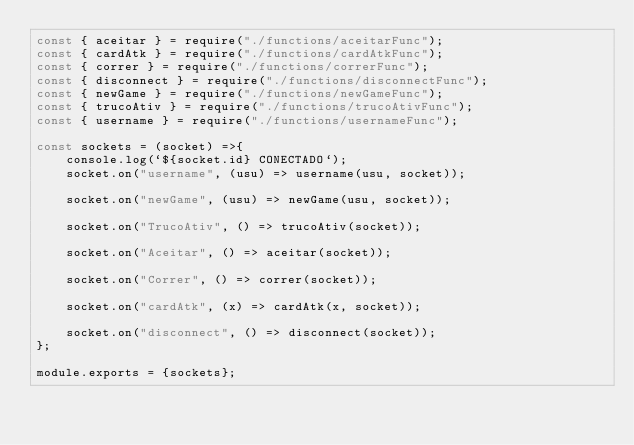Convert code to text. <code><loc_0><loc_0><loc_500><loc_500><_JavaScript_>const { aceitar } = require("./functions/aceitarFunc");
const { cardAtk } = require("./functions/cardAtkFunc");
const { correr } = require("./functions/correrFunc");
const { disconnect } = require("./functions/disconnectFunc");
const { newGame } = require("./functions/newGameFunc");
const { trucoAtiv } = require("./functions/trucoAtivFunc");
const { username } = require("./functions/usernameFunc");

const sockets = (socket) =>{
    console.log(`${socket.id} CONECTADO`);
    socket.on("username", (usu) => username(usu, socket));
    
    socket.on("newGame", (usu) => newGame(usu, socket));

    socket.on("TrucoAtiv", () => trucoAtiv(socket));

    socket.on("Aceitar", () => aceitar(socket));
    
    socket.on("Correr", () => correr(socket));

    socket.on("cardAtk", (x) => cardAtk(x, socket));

    socket.on("disconnect", () => disconnect(socket));
};

module.exports = {sockets};
</code> 